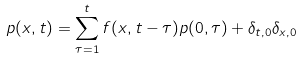Convert formula to latex. <formula><loc_0><loc_0><loc_500><loc_500>p ( x , t ) = \sum _ { \tau = 1 } ^ { t } f ( x , t - \tau ) p ( 0 , \tau ) + \delta _ { t , 0 } \delta _ { x , 0 }</formula> 